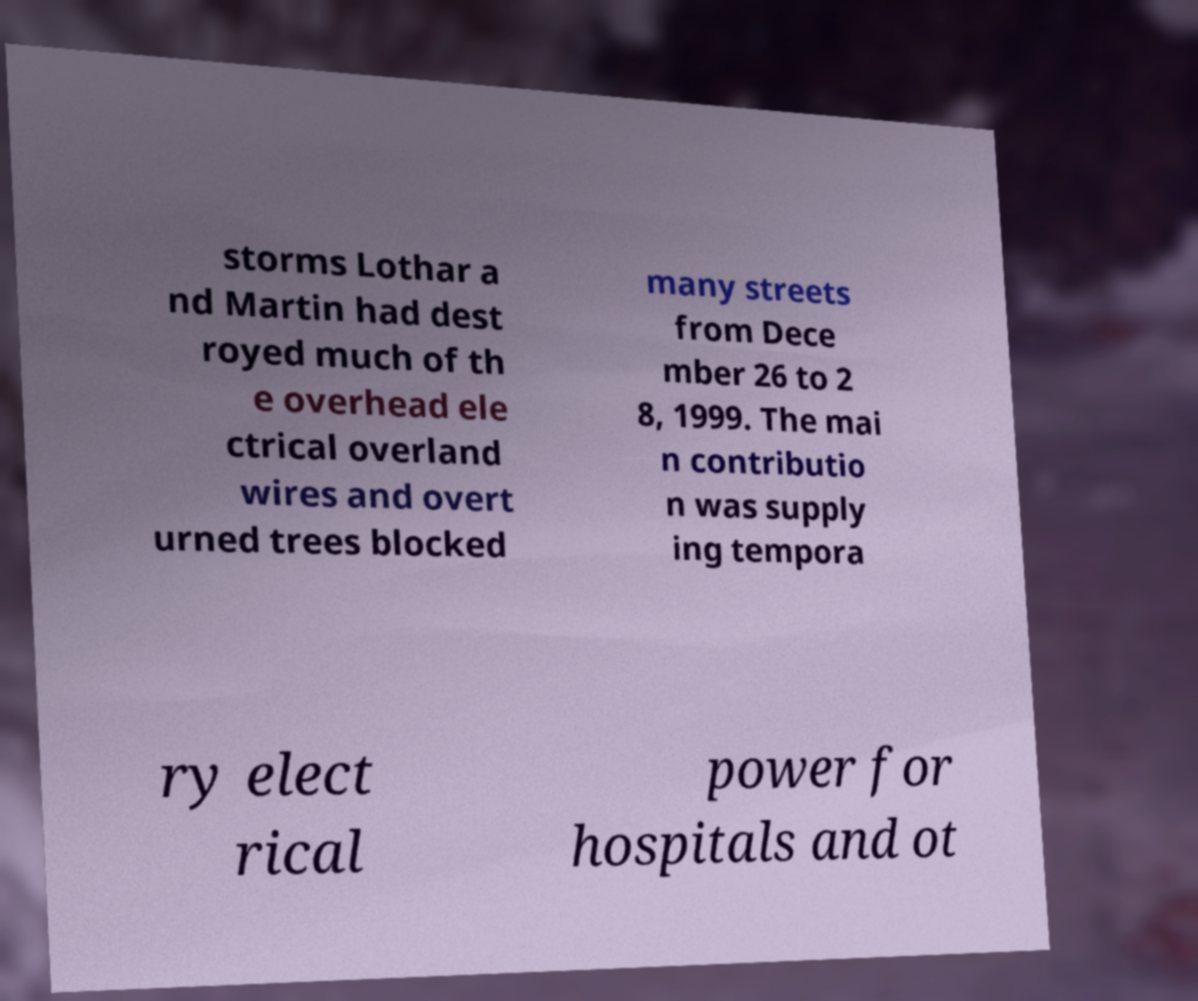Can you accurately transcribe the text from the provided image for me? storms Lothar a nd Martin had dest royed much of th e overhead ele ctrical overland wires and overt urned trees blocked many streets from Dece mber 26 to 2 8, 1999. The mai n contributio n was supply ing tempora ry elect rical power for hospitals and ot 